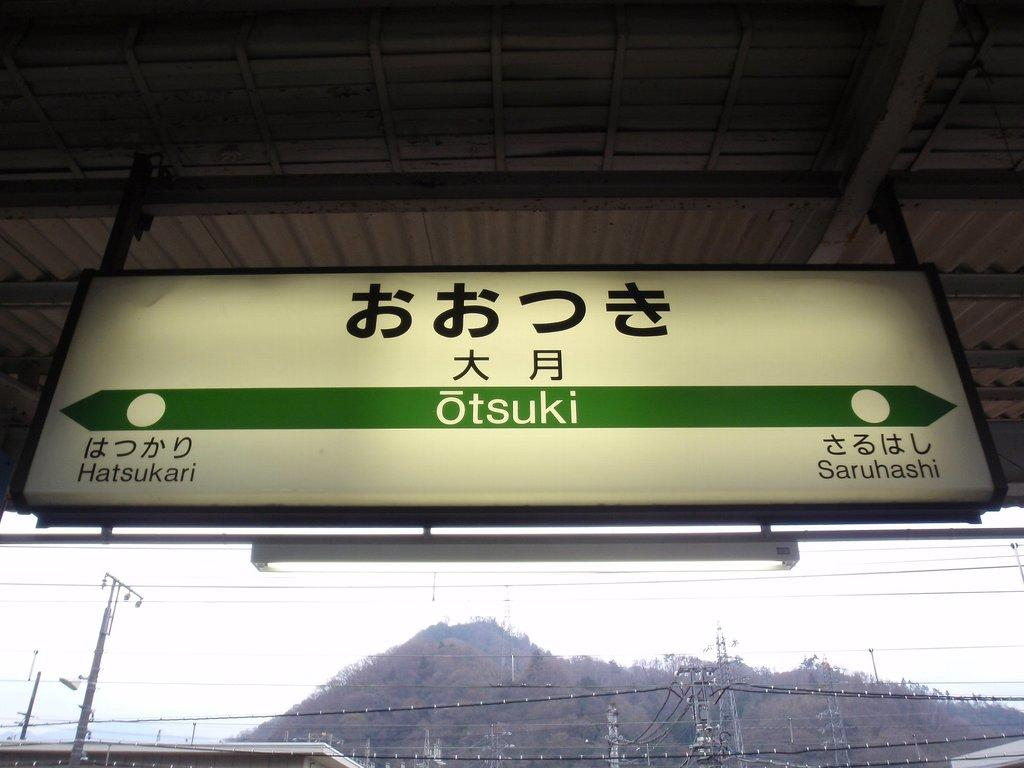Provide a one-sentence caption for the provided image. a otsuki travel sign with directions to hatsukari or saruhashi. 